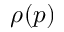Convert formula to latex. <formula><loc_0><loc_0><loc_500><loc_500>\rho ( p )</formula> 